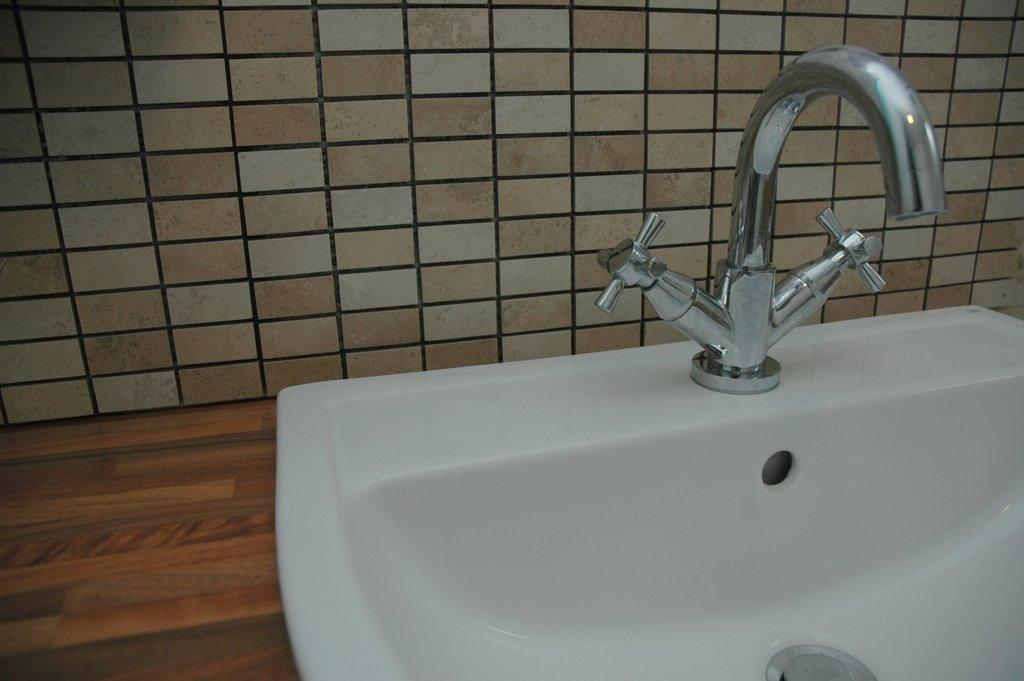What is the main object in the image? There is a white sink in the image. What feature is present on the sink? The sink has a tap. On what surface is the sink placed? The sink is on a surface. How close is the sink to a wall in the image? The sink is near to a wall. What type of thrill can be experienced by the underwear in the image? There is no underwear present in the image, and therefore no such experience can be observed. 